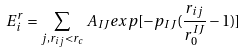<formula> <loc_0><loc_0><loc_500><loc_500>E _ { i } ^ { r } = \sum _ { j , r _ { i j } < r _ { c } } A _ { I J } e x p [ - p _ { I J } ( \frac { r _ { i j } } { r ^ { I J } _ { 0 } } - 1 ) ]</formula> 